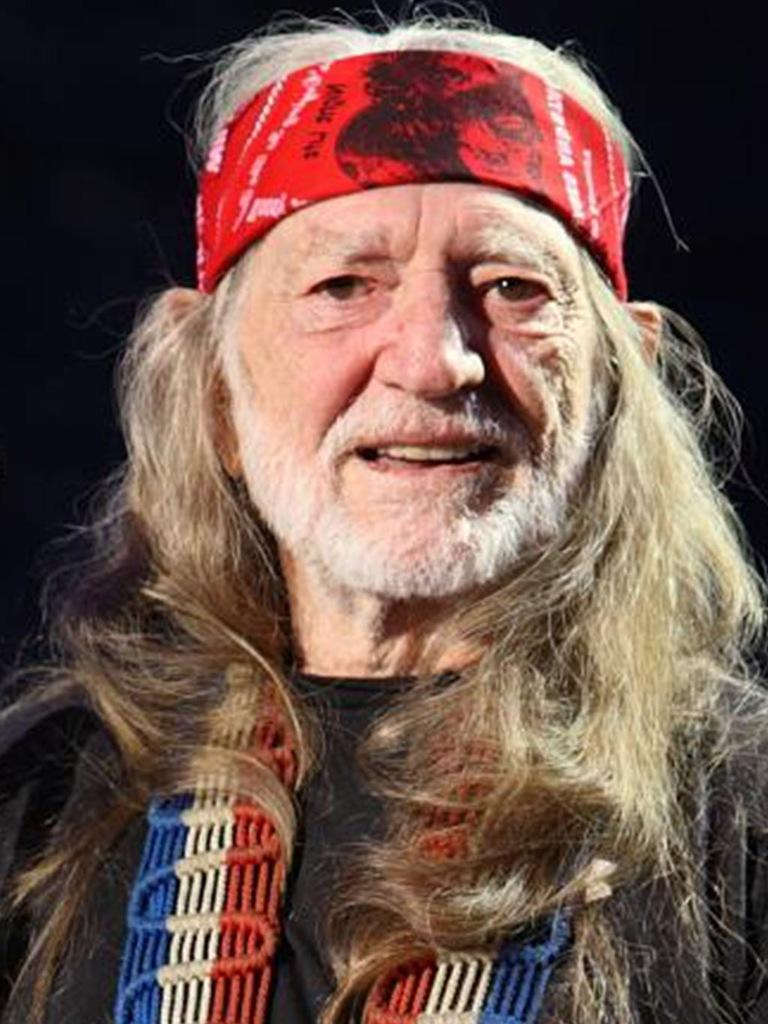Who is present in the image? There is a man in the image. What is on the man's head? The man has a cloth on his head. What is the man's facial expression? The man is smiling. What color is the background of the image? The background of the image is black. What books can be seen on the shelf in the bedroom in the image? There is no mention of books or a bedroom in the image; it features a man with a cloth on his head and a black background. 